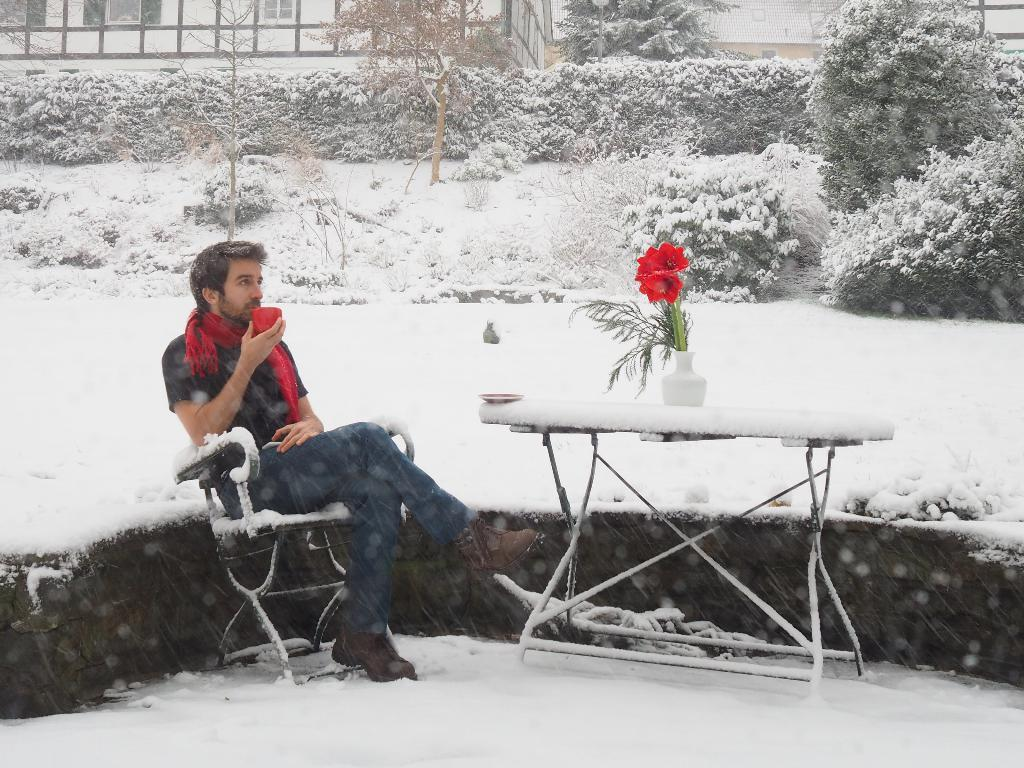What type of structure is visible in the image? There is a building in the image. What is the weather like in the image? There is snow in the image, indicating a cold or wintery environment. What type of vegetation can be seen in the image? There are trees and plants in the image. What type of flowers are present in the image? There are red color flowers in the image. What is the man in the image holding? The man is holding a cup in the image. What is the man's position in the image? The man is sitting on a chair in the image. Where is the sister of the man in the image? There is no mention of a sister in the image or the provided facts. How many cars are parked near the building in the image? There is no mention of cars in the image or the provided facts. 